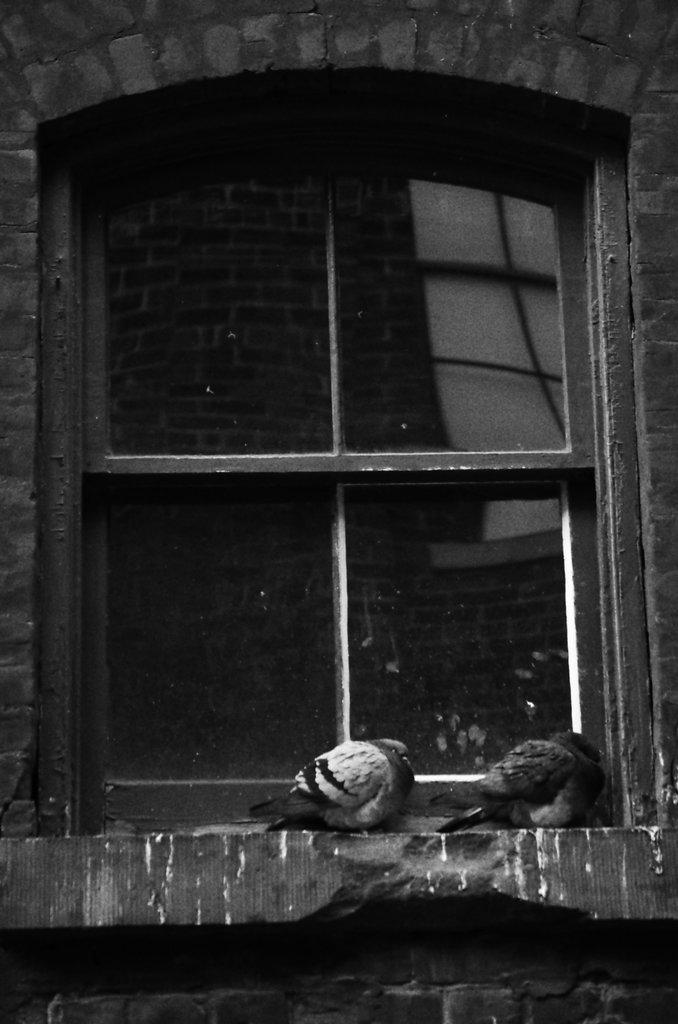What type of animals can be seen in the image? There are birds in the image. What can be seen through the window in the image? There is a reflection of a wall on the window glass. Can you describe the window in the image? Yes, there is a window in the image. What type of fuel is being used by the birds in the image? There is no mention of fuel in the image, as birds do not use fuel for their activities. 